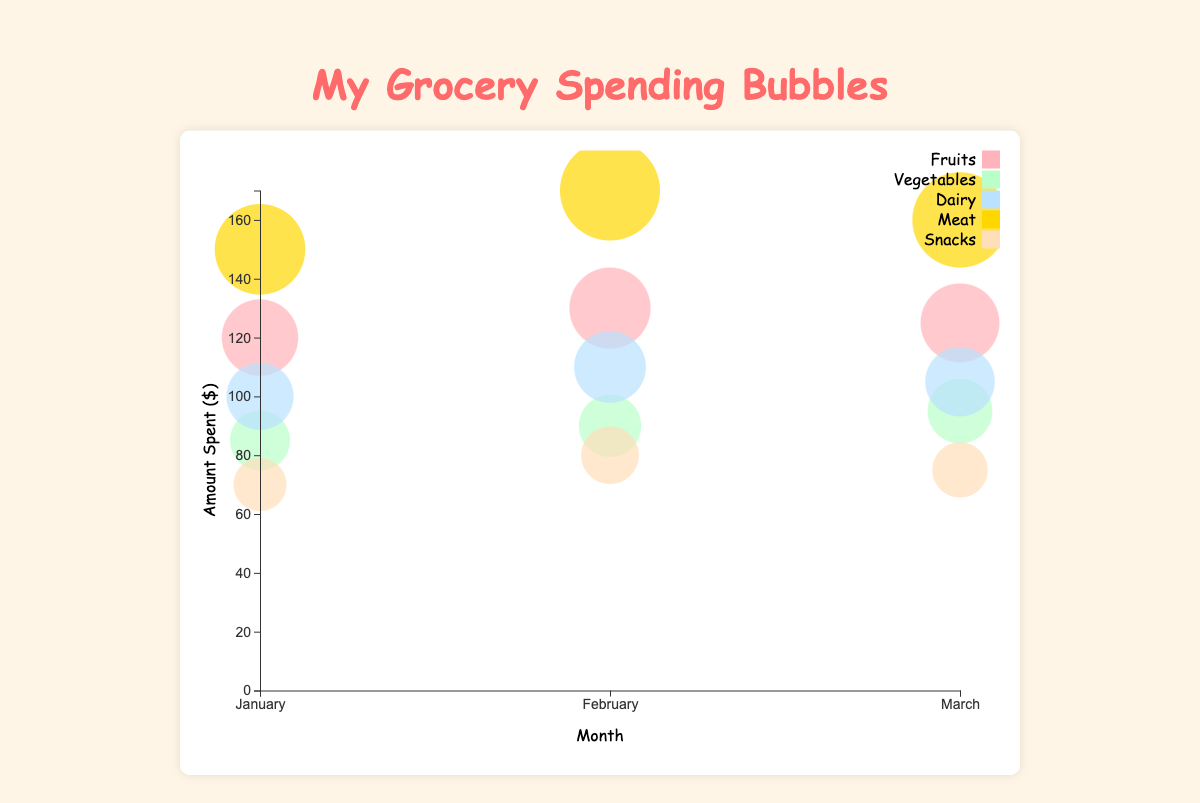What category had the highest spending in January? To find the category with the highest spending in January, look at the bubbles corresponding to January and compare their sizes. The largest bubble in January is for Meat, with an amount of $150.
Answer: Meat What was the total amount spent on Fruits over the three months? Sum the amounts spent on Fruits in January, February, and March. The amounts are $120, $130, and $125, respectively. Therefore, the total amount spent is 120 + 130 + 125 = 375.
Answer: 375 How does the spending on Vegetables in February compare to January? Look at the size of the bubbles for Vegetables in January and February. In January, the amount is $85, and in February, it is $90. So, the spending increased in February.
Answer: Increased Which month saw the highest spending on Dairy? Compare the bubbles for Dairy across the three months. The spending amounts are $100 in January, $110 in February, and $105 in March. February has the highest spending on Dairy.
Answer: February What is the average amount spent on Snacks per month? Sum the amounts spent on Snacks over the three months and divide by three. The amounts are $70, $80, and $75. So, the average is (70 + 80 + 75)/3 = 225/3 = 75.
Answer: 75 How many categories had increasing spending from January to February? Compare the spending amounts for each category from January to February. Fruits ($120 to $130), Dairy ($100 to $110), Meat ($150 to $170), and Snacks ($70 to $80) increased. Vegetables also increased ($85 to $90). So, five categories increased.
Answer: 5 Which category had the most consistent spending across the three months? Look at the bubbles for each category across the three months and observe which has the smallest variation. Snacks vary between $70, $80, and $75, which seems quite consistent compared to others.
Answer: Snacks What was the spending change for Dairy from February to March? Compare the bubble sizes for Dairy in February and March. The amounts are $110 in February and $105 in March. The change is $110 - $105 = $5.
Answer: Decrease of $5 In which month was the total spending amount the highest? Sum the spending amounts for each month. January: 120 + 85 + 100 + 150 + 70 = 525, February: 130 + 90 + 110 + 170 + 80 = 580, March: 125 + 95 + 105 + 160 + 75 = 560. February has the highest total spending.
Answer: February 